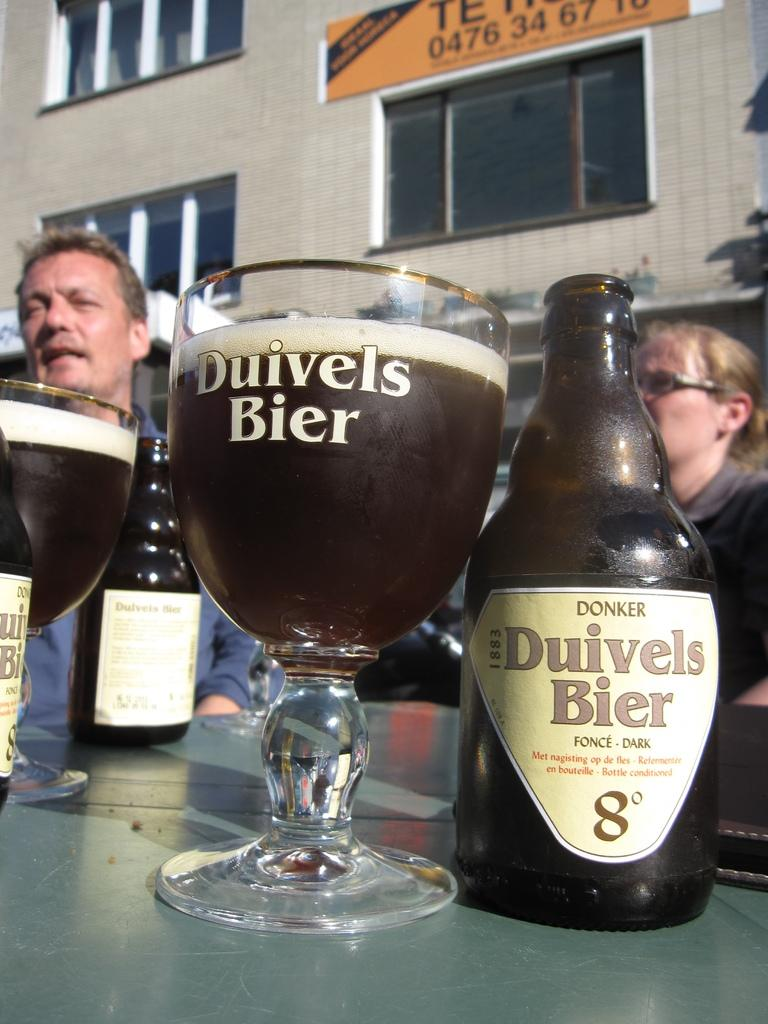<image>
Describe the image concisely. table with bottles and glasses of donker duivels bier on it 